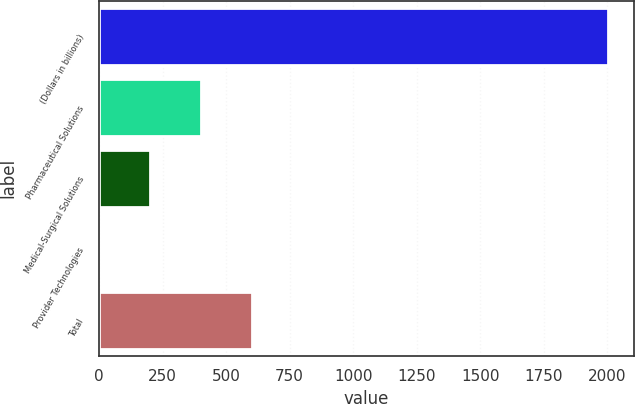Convert chart. <chart><loc_0><loc_0><loc_500><loc_500><bar_chart><fcel>(Dollars in billions)<fcel>Pharmaceutical Solutions<fcel>Medical-Surgical Solutions<fcel>Provider Technologies<fcel>Total<nl><fcel>2005<fcel>401.8<fcel>201.4<fcel>1<fcel>602.2<nl></chart> 